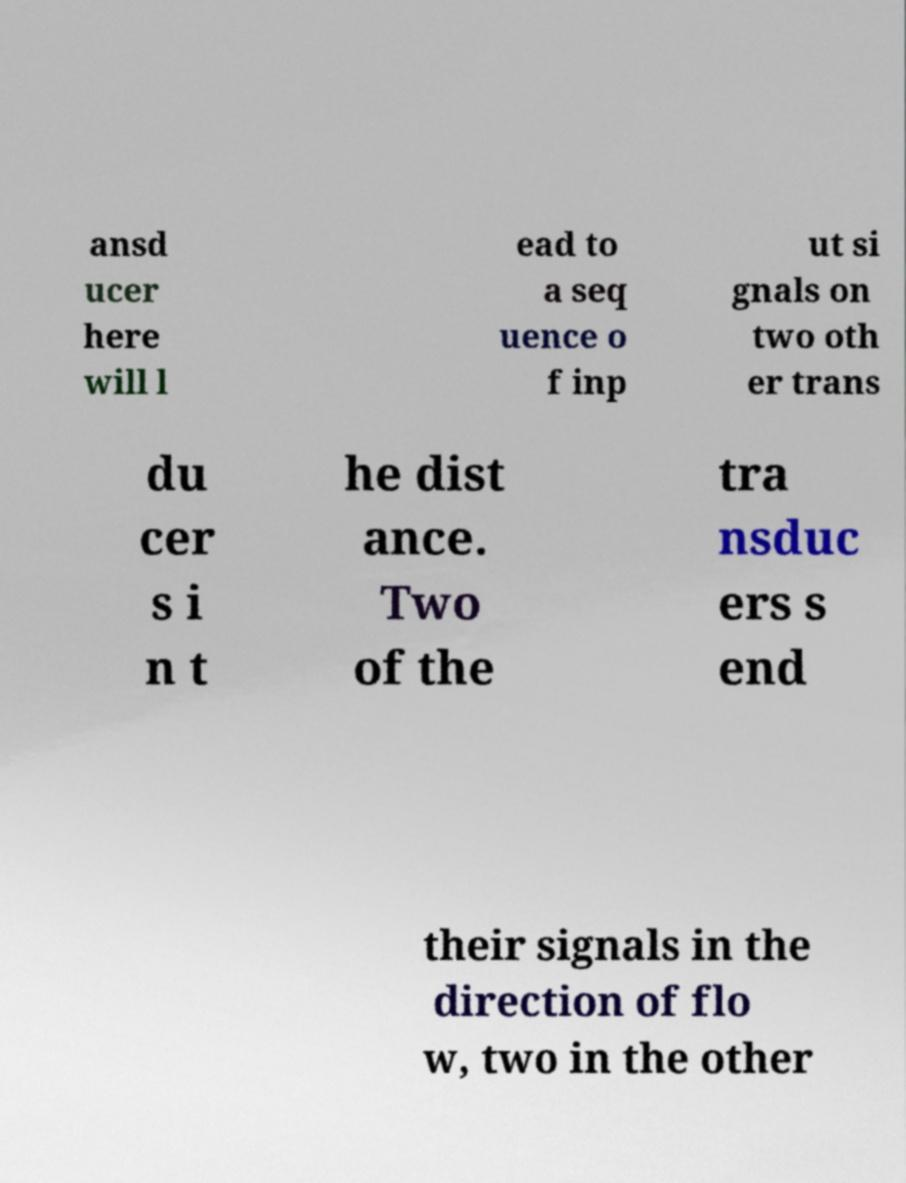Can you accurately transcribe the text from the provided image for me? ansd ucer here will l ead to a seq uence o f inp ut si gnals on two oth er trans du cer s i n t he dist ance. Two of the tra nsduc ers s end their signals in the direction of flo w, two in the other 